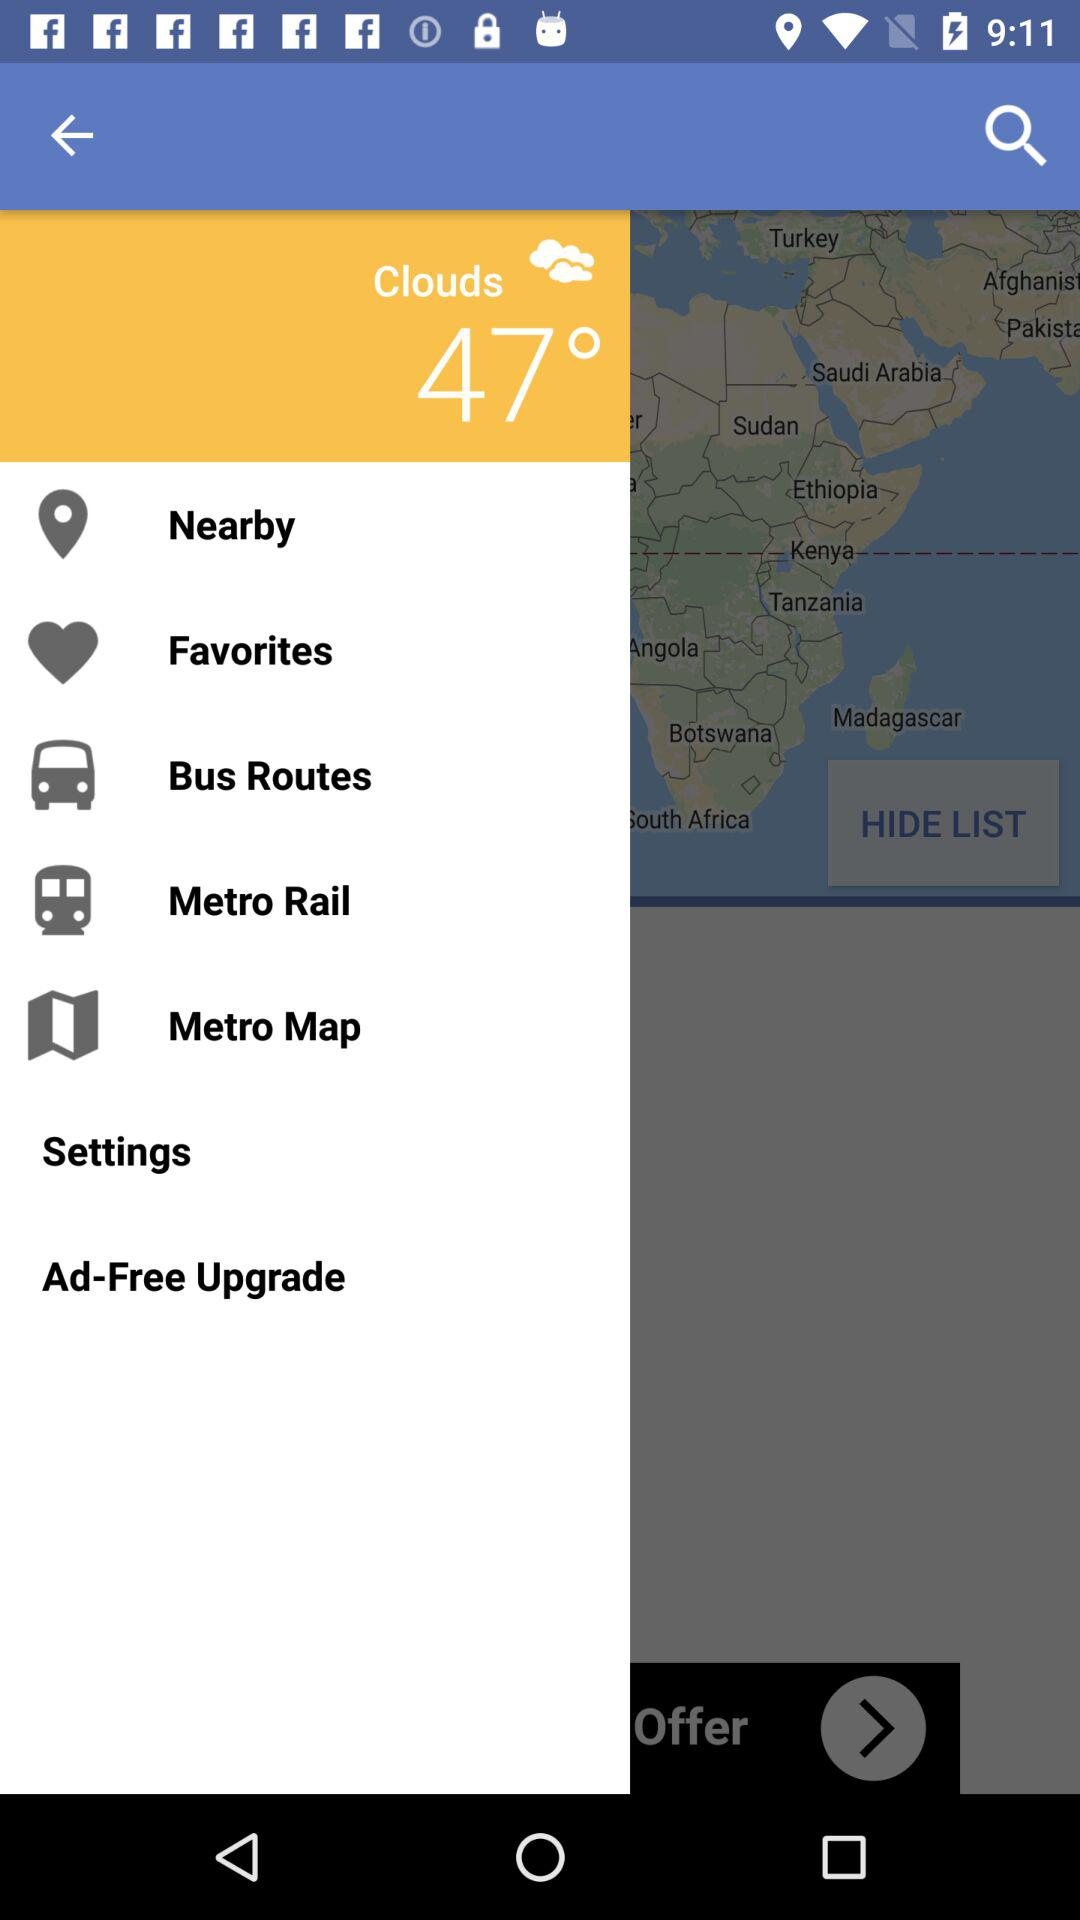What is the temperature shown on the screen? The temperature is 47°. 